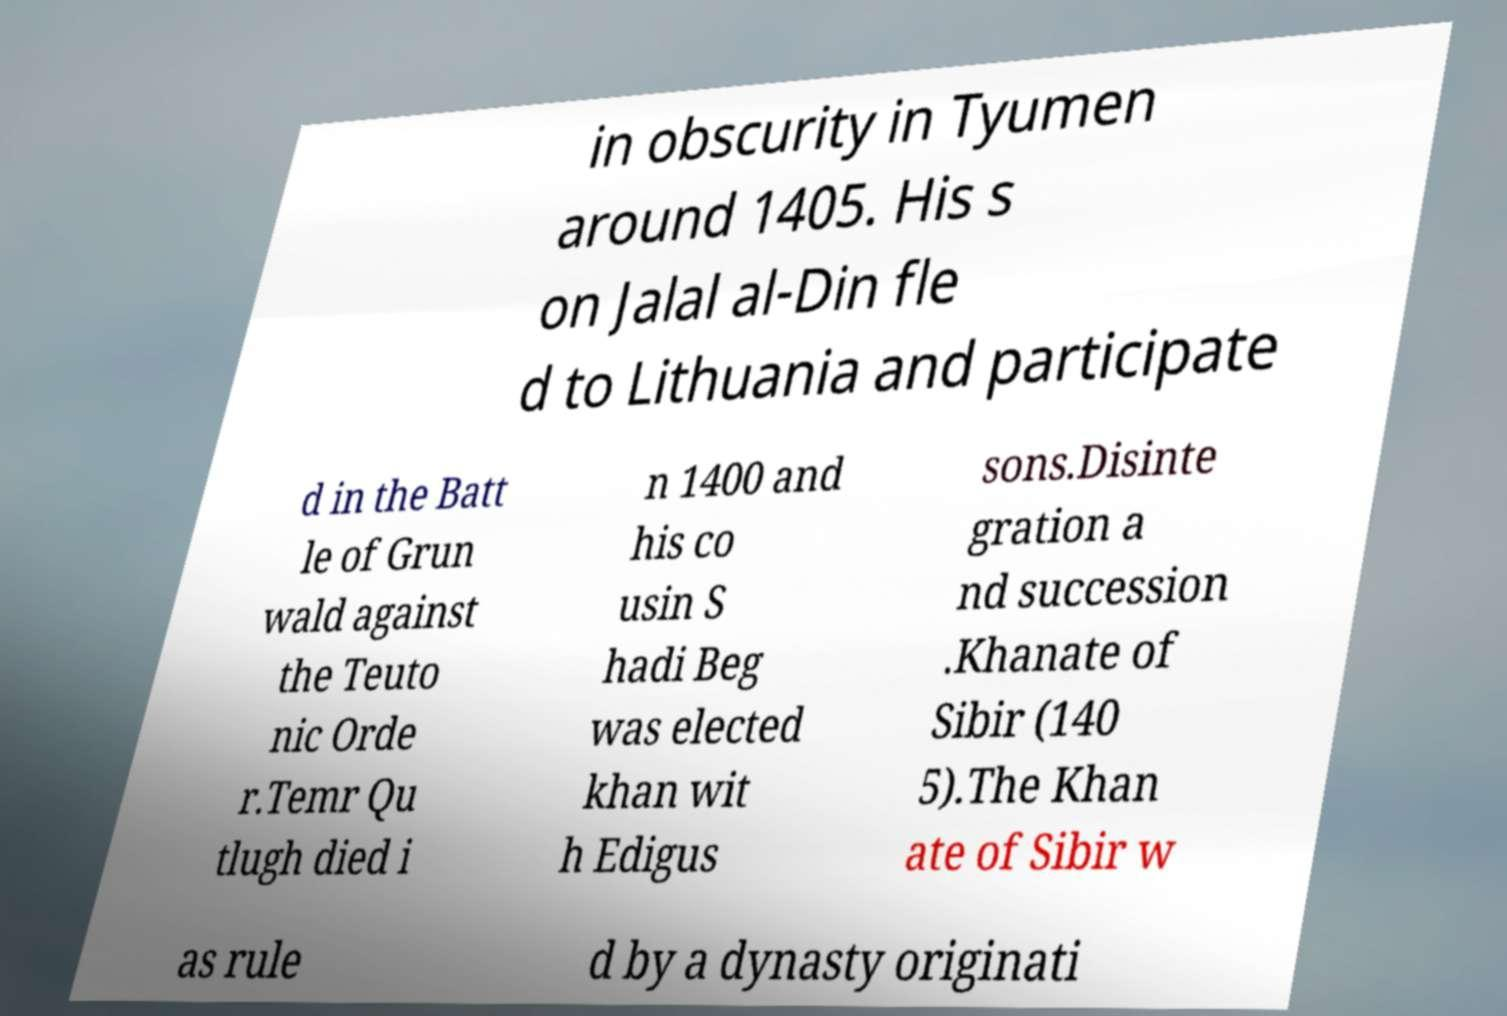Could you assist in decoding the text presented in this image and type it out clearly? in obscurity in Tyumen around 1405. His s on Jalal al-Din fle d to Lithuania and participate d in the Batt le of Grun wald against the Teuto nic Orde r.Temr Qu tlugh died i n 1400 and his co usin S hadi Beg was elected khan wit h Edigus sons.Disinte gration a nd succession .Khanate of Sibir (140 5).The Khan ate of Sibir w as rule d by a dynasty originati 